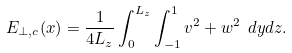<formula> <loc_0><loc_0><loc_500><loc_500>E _ { \perp , c } ( x ) = \frac { 1 } { 4 L _ { z } } \int _ { 0 } ^ { L _ { z } } \int _ { - 1 } ^ { 1 } v ^ { 2 } + w ^ { 2 } \ d y d z .</formula> 